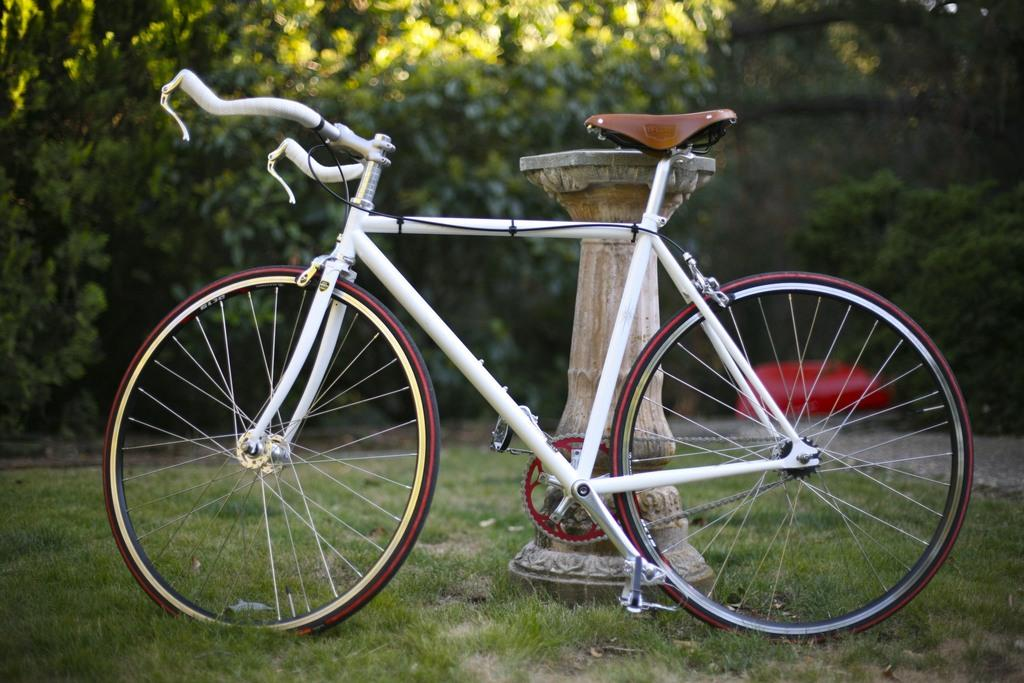What is the main object in the foreground of the image? There is a bicycle in the foreground of the image. Where is the bicycle located? The bicycle is on the grass. What can be seen near the bicycle? There is a pole-like structure near the bicycle. What is visible in the background of the image? There are trees and a red color object in the background of the image. What type of stew is being prepared in the image? There is no stew present in the image; it features a bicycle on the grass with a pole-like structure nearby and trees and a red color object in the background. How does the person in the image express their hate towards the bicycle? There is no person expressing hate towards the bicycle in the image; it simply shows a bicycle on the grass with a pole-like structure nearby and trees and a red color object in the background. 